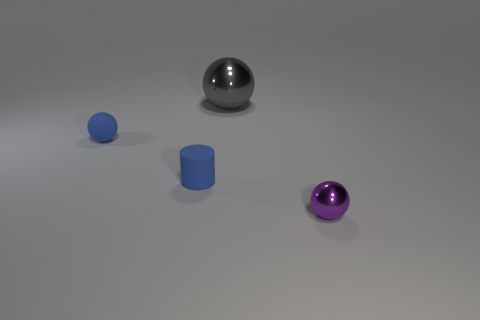Add 1 tiny purple shiny balls. How many objects exist? 5 Subtract all balls. How many objects are left? 1 Add 3 big yellow cylinders. How many big yellow cylinders exist? 3 Subtract 0 blue cubes. How many objects are left? 4 Subtract all purple things. Subtract all large blue blocks. How many objects are left? 3 Add 3 blue rubber balls. How many blue rubber balls are left? 4 